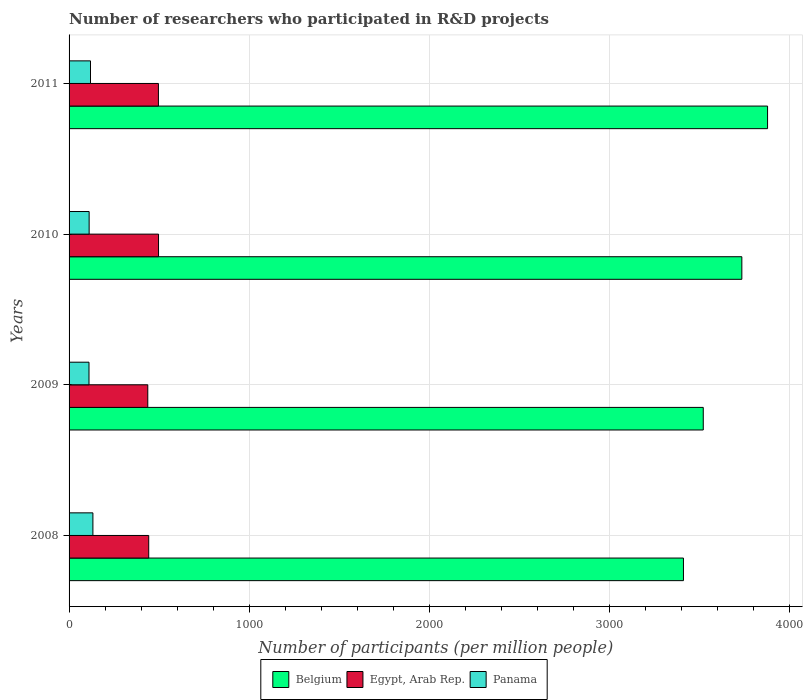How many different coloured bars are there?
Your answer should be compact. 3. Are the number of bars on each tick of the Y-axis equal?
Offer a very short reply. Yes. How many bars are there on the 4th tick from the top?
Your response must be concise. 3. In how many cases, is the number of bars for a given year not equal to the number of legend labels?
Offer a terse response. 0. What is the number of researchers who participated in R&D projects in Egypt, Arab Rep. in 2010?
Give a very brief answer. 496.73. Across all years, what is the maximum number of researchers who participated in R&D projects in Panama?
Offer a terse response. 132.34. Across all years, what is the minimum number of researchers who participated in R&D projects in Egypt, Arab Rep.?
Ensure brevity in your answer.  437.06. In which year was the number of researchers who participated in R&D projects in Panama maximum?
Ensure brevity in your answer.  2008. In which year was the number of researchers who participated in R&D projects in Panama minimum?
Provide a succinct answer. 2009. What is the total number of researchers who participated in R&D projects in Panama in the graph?
Offer a very short reply. 473.46. What is the difference between the number of researchers who participated in R&D projects in Panama in 2009 and that in 2010?
Provide a succinct answer. -0.78. What is the difference between the number of researchers who participated in R&D projects in Belgium in 2010 and the number of researchers who participated in R&D projects in Panama in 2008?
Provide a short and direct response. 3603.49. What is the average number of researchers who participated in R&D projects in Belgium per year?
Provide a short and direct response. 3636.95. In the year 2009, what is the difference between the number of researchers who participated in R&D projects in Belgium and number of researchers who participated in R&D projects in Egypt, Arab Rep.?
Offer a terse response. 3084.6. What is the ratio of the number of researchers who participated in R&D projects in Egypt, Arab Rep. in 2008 to that in 2011?
Provide a short and direct response. 0.89. Is the number of researchers who participated in R&D projects in Egypt, Arab Rep. in 2009 less than that in 2011?
Offer a terse response. Yes. What is the difference between the highest and the second highest number of researchers who participated in R&D projects in Belgium?
Give a very brief answer. 142.88. What is the difference between the highest and the lowest number of researchers who participated in R&D projects in Egypt, Arab Rep.?
Your answer should be compact. 59.67. In how many years, is the number of researchers who participated in R&D projects in Panama greater than the average number of researchers who participated in R&D projects in Panama taken over all years?
Offer a very short reply. 2. What does the 2nd bar from the top in 2011 represents?
Ensure brevity in your answer.  Egypt, Arab Rep. What does the 3rd bar from the bottom in 2009 represents?
Your response must be concise. Panama. How many years are there in the graph?
Ensure brevity in your answer.  4. What is the difference between two consecutive major ticks on the X-axis?
Your response must be concise. 1000. Are the values on the major ticks of X-axis written in scientific E-notation?
Offer a very short reply. No. Does the graph contain grids?
Provide a succinct answer. Yes. Where does the legend appear in the graph?
Ensure brevity in your answer.  Bottom center. What is the title of the graph?
Your answer should be very brief. Number of researchers who participated in R&D projects. Does "Liberia" appear as one of the legend labels in the graph?
Ensure brevity in your answer.  No. What is the label or title of the X-axis?
Your answer should be very brief. Number of participants (per million people). What is the Number of participants (per million people) of Belgium in 2008?
Keep it short and to the point. 3411.63. What is the Number of participants (per million people) in Egypt, Arab Rep. in 2008?
Offer a terse response. 442.27. What is the Number of participants (per million people) in Panama in 2008?
Your response must be concise. 132.34. What is the Number of participants (per million people) of Belgium in 2009?
Your response must be concise. 3521.66. What is the Number of participants (per million people) of Egypt, Arab Rep. in 2009?
Your answer should be compact. 437.06. What is the Number of participants (per million people) of Panama in 2009?
Provide a succinct answer. 110.69. What is the Number of participants (per million people) in Belgium in 2010?
Provide a succinct answer. 3735.82. What is the Number of participants (per million people) in Egypt, Arab Rep. in 2010?
Your response must be concise. 496.73. What is the Number of participants (per million people) in Panama in 2010?
Keep it short and to the point. 111.47. What is the Number of participants (per million people) in Belgium in 2011?
Your answer should be compact. 3878.7. What is the Number of participants (per million people) of Egypt, Arab Rep. in 2011?
Ensure brevity in your answer.  496.12. What is the Number of participants (per million people) of Panama in 2011?
Offer a very short reply. 118.96. Across all years, what is the maximum Number of participants (per million people) of Belgium?
Your answer should be compact. 3878.7. Across all years, what is the maximum Number of participants (per million people) in Egypt, Arab Rep.?
Your answer should be very brief. 496.73. Across all years, what is the maximum Number of participants (per million people) in Panama?
Your answer should be very brief. 132.34. Across all years, what is the minimum Number of participants (per million people) in Belgium?
Your response must be concise. 3411.63. Across all years, what is the minimum Number of participants (per million people) of Egypt, Arab Rep.?
Make the answer very short. 437.06. Across all years, what is the minimum Number of participants (per million people) in Panama?
Your answer should be compact. 110.69. What is the total Number of participants (per million people) in Belgium in the graph?
Make the answer very short. 1.45e+04. What is the total Number of participants (per million people) of Egypt, Arab Rep. in the graph?
Keep it short and to the point. 1872.17. What is the total Number of participants (per million people) of Panama in the graph?
Your answer should be compact. 473.46. What is the difference between the Number of participants (per million people) in Belgium in 2008 and that in 2009?
Your response must be concise. -110.03. What is the difference between the Number of participants (per million people) of Egypt, Arab Rep. in 2008 and that in 2009?
Offer a very short reply. 5.21. What is the difference between the Number of participants (per million people) of Panama in 2008 and that in 2009?
Offer a very short reply. 21.64. What is the difference between the Number of participants (per million people) of Belgium in 2008 and that in 2010?
Make the answer very short. -324.2. What is the difference between the Number of participants (per million people) in Egypt, Arab Rep. in 2008 and that in 2010?
Provide a succinct answer. -54.46. What is the difference between the Number of participants (per million people) of Panama in 2008 and that in 2010?
Ensure brevity in your answer.  20.87. What is the difference between the Number of participants (per million people) in Belgium in 2008 and that in 2011?
Provide a succinct answer. -467.07. What is the difference between the Number of participants (per million people) in Egypt, Arab Rep. in 2008 and that in 2011?
Your response must be concise. -53.85. What is the difference between the Number of participants (per million people) in Panama in 2008 and that in 2011?
Make the answer very short. 13.38. What is the difference between the Number of participants (per million people) in Belgium in 2009 and that in 2010?
Provide a short and direct response. -214.17. What is the difference between the Number of participants (per million people) in Egypt, Arab Rep. in 2009 and that in 2010?
Your answer should be compact. -59.67. What is the difference between the Number of participants (per million people) in Panama in 2009 and that in 2010?
Offer a terse response. -0.78. What is the difference between the Number of participants (per million people) of Belgium in 2009 and that in 2011?
Ensure brevity in your answer.  -357.04. What is the difference between the Number of participants (per million people) of Egypt, Arab Rep. in 2009 and that in 2011?
Give a very brief answer. -59.06. What is the difference between the Number of participants (per million people) of Panama in 2009 and that in 2011?
Offer a terse response. -8.27. What is the difference between the Number of participants (per million people) in Belgium in 2010 and that in 2011?
Provide a succinct answer. -142.88. What is the difference between the Number of participants (per million people) of Egypt, Arab Rep. in 2010 and that in 2011?
Offer a very short reply. 0.61. What is the difference between the Number of participants (per million people) in Panama in 2010 and that in 2011?
Ensure brevity in your answer.  -7.49. What is the difference between the Number of participants (per million people) in Belgium in 2008 and the Number of participants (per million people) in Egypt, Arab Rep. in 2009?
Provide a short and direct response. 2974.57. What is the difference between the Number of participants (per million people) in Belgium in 2008 and the Number of participants (per million people) in Panama in 2009?
Your answer should be compact. 3300.93. What is the difference between the Number of participants (per million people) of Egypt, Arab Rep. in 2008 and the Number of participants (per million people) of Panama in 2009?
Offer a terse response. 331.58. What is the difference between the Number of participants (per million people) in Belgium in 2008 and the Number of participants (per million people) in Egypt, Arab Rep. in 2010?
Offer a terse response. 2914.9. What is the difference between the Number of participants (per million people) of Belgium in 2008 and the Number of participants (per million people) of Panama in 2010?
Make the answer very short. 3300.16. What is the difference between the Number of participants (per million people) of Egypt, Arab Rep. in 2008 and the Number of participants (per million people) of Panama in 2010?
Your answer should be very brief. 330.8. What is the difference between the Number of participants (per million people) of Belgium in 2008 and the Number of participants (per million people) of Egypt, Arab Rep. in 2011?
Make the answer very short. 2915.51. What is the difference between the Number of participants (per million people) of Belgium in 2008 and the Number of participants (per million people) of Panama in 2011?
Your response must be concise. 3292.67. What is the difference between the Number of participants (per million people) of Egypt, Arab Rep. in 2008 and the Number of participants (per million people) of Panama in 2011?
Your answer should be compact. 323.31. What is the difference between the Number of participants (per million people) of Belgium in 2009 and the Number of participants (per million people) of Egypt, Arab Rep. in 2010?
Make the answer very short. 3024.93. What is the difference between the Number of participants (per million people) in Belgium in 2009 and the Number of participants (per million people) in Panama in 2010?
Offer a very short reply. 3410.19. What is the difference between the Number of participants (per million people) of Egypt, Arab Rep. in 2009 and the Number of participants (per million people) of Panama in 2010?
Give a very brief answer. 325.59. What is the difference between the Number of participants (per million people) in Belgium in 2009 and the Number of participants (per million people) in Egypt, Arab Rep. in 2011?
Provide a short and direct response. 3025.54. What is the difference between the Number of participants (per million people) of Belgium in 2009 and the Number of participants (per million people) of Panama in 2011?
Make the answer very short. 3402.7. What is the difference between the Number of participants (per million people) in Egypt, Arab Rep. in 2009 and the Number of participants (per million people) in Panama in 2011?
Offer a terse response. 318.1. What is the difference between the Number of participants (per million people) of Belgium in 2010 and the Number of participants (per million people) of Egypt, Arab Rep. in 2011?
Offer a very short reply. 3239.71. What is the difference between the Number of participants (per million people) in Belgium in 2010 and the Number of participants (per million people) in Panama in 2011?
Give a very brief answer. 3616.87. What is the difference between the Number of participants (per million people) of Egypt, Arab Rep. in 2010 and the Number of participants (per million people) of Panama in 2011?
Provide a succinct answer. 377.77. What is the average Number of participants (per million people) in Belgium per year?
Make the answer very short. 3636.95. What is the average Number of participants (per million people) of Egypt, Arab Rep. per year?
Offer a very short reply. 468.04. What is the average Number of participants (per million people) in Panama per year?
Offer a very short reply. 118.36. In the year 2008, what is the difference between the Number of participants (per million people) in Belgium and Number of participants (per million people) in Egypt, Arab Rep.?
Your answer should be very brief. 2969.36. In the year 2008, what is the difference between the Number of participants (per million people) in Belgium and Number of participants (per million people) in Panama?
Offer a very short reply. 3279.29. In the year 2008, what is the difference between the Number of participants (per million people) of Egypt, Arab Rep. and Number of participants (per million people) of Panama?
Make the answer very short. 309.93. In the year 2009, what is the difference between the Number of participants (per million people) of Belgium and Number of participants (per million people) of Egypt, Arab Rep.?
Your response must be concise. 3084.6. In the year 2009, what is the difference between the Number of participants (per million people) in Belgium and Number of participants (per million people) in Panama?
Offer a very short reply. 3410.96. In the year 2009, what is the difference between the Number of participants (per million people) of Egypt, Arab Rep. and Number of participants (per million people) of Panama?
Keep it short and to the point. 326.37. In the year 2010, what is the difference between the Number of participants (per million people) in Belgium and Number of participants (per million people) in Egypt, Arab Rep.?
Your answer should be compact. 3239.09. In the year 2010, what is the difference between the Number of participants (per million people) in Belgium and Number of participants (per million people) in Panama?
Your answer should be very brief. 3624.35. In the year 2010, what is the difference between the Number of participants (per million people) of Egypt, Arab Rep. and Number of participants (per million people) of Panama?
Provide a succinct answer. 385.26. In the year 2011, what is the difference between the Number of participants (per million people) in Belgium and Number of participants (per million people) in Egypt, Arab Rep.?
Provide a short and direct response. 3382.58. In the year 2011, what is the difference between the Number of participants (per million people) in Belgium and Number of participants (per million people) in Panama?
Make the answer very short. 3759.74. In the year 2011, what is the difference between the Number of participants (per million people) of Egypt, Arab Rep. and Number of participants (per million people) of Panama?
Ensure brevity in your answer.  377.16. What is the ratio of the Number of participants (per million people) of Belgium in 2008 to that in 2009?
Ensure brevity in your answer.  0.97. What is the ratio of the Number of participants (per million people) in Egypt, Arab Rep. in 2008 to that in 2009?
Provide a succinct answer. 1.01. What is the ratio of the Number of participants (per million people) of Panama in 2008 to that in 2009?
Your answer should be compact. 1.2. What is the ratio of the Number of participants (per million people) in Belgium in 2008 to that in 2010?
Your answer should be very brief. 0.91. What is the ratio of the Number of participants (per million people) of Egypt, Arab Rep. in 2008 to that in 2010?
Your answer should be compact. 0.89. What is the ratio of the Number of participants (per million people) of Panama in 2008 to that in 2010?
Make the answer very short. 1.19. What is the ratio of the Number of participants (per million people) of Belgium in 2008 to that in 2011?
Your answer should be very brief. 0.88. What is the ratio of the Number of participants (per million people) of Egypt, Arab Rep. in 2008 to that in 2011?
Provide a succinct answer. 0.89. What is the ratio of the Number of participants (per million people) in Panama in 2008 to that in 2011?
Provide a short and direct response. 1.11. What is the ratio of the Number of participants (per million people) in Belgium in 2009 to that in 2010?
Provide a succinct answer. 0.94. What is the ratio of the Number of participants (per million people) in Egypt, Arab Rep. in 2009 to that in 2010?
Provide a short and direct response. 0.88. What is the ratio of the Number of participants (per million people) of Belgium in 2009 to that in 2011?
Your answer should be compact. 0.91. What is the ratio of the Number of participants (per million people) in Egypt, Arab Rep. in 2009 to that in 2011?
Give a very brief answer. 0.88. What is the ratio of the Number of participants (per million people) of Panama in 2009 to that in 2011?
Provide a short and direct response. 0.93. What is the ratio of the Number of participants (per million people) in Belgium in 2010 to that in 2011?
Offer a very short reply. 0.96. What is the ratio of the Number of participants (per million people) in Egypt, Arab Rep. in 2010 to that in 2011?
Ensure brevity in your answer.  1. What is the ratio of the Number of participants (per million people) in Panama in 2010 to that in 2011?
Offer a very short reply. 0.94. What is the difference between the highest and the second highest Number of participants (per million people) of Belgium?
Offer a terse response. 142.88. What is the difference between the highest and the second highest Number of participants (per million people) of Egypt, Arab Rep.?
Provide a short and direct response. 0.61. What is the difference between the highest and the second highest Number of participants (per million people) of Panama?
Provide a succinct answer. 13.38. What is the difference between the highest and the lowest Number of participants (per million people) of Belgium?
Your answer should be compact. 467.07. What is the difference between the highest and the lowest Number of participants (per million people) in Egypt, Arab Rep.?
Your answer should be compact. 59.67. What is the difference between the highest and the lowest Number of participants (per million people) of Panama?
Your answer should be compact. 21.64. 